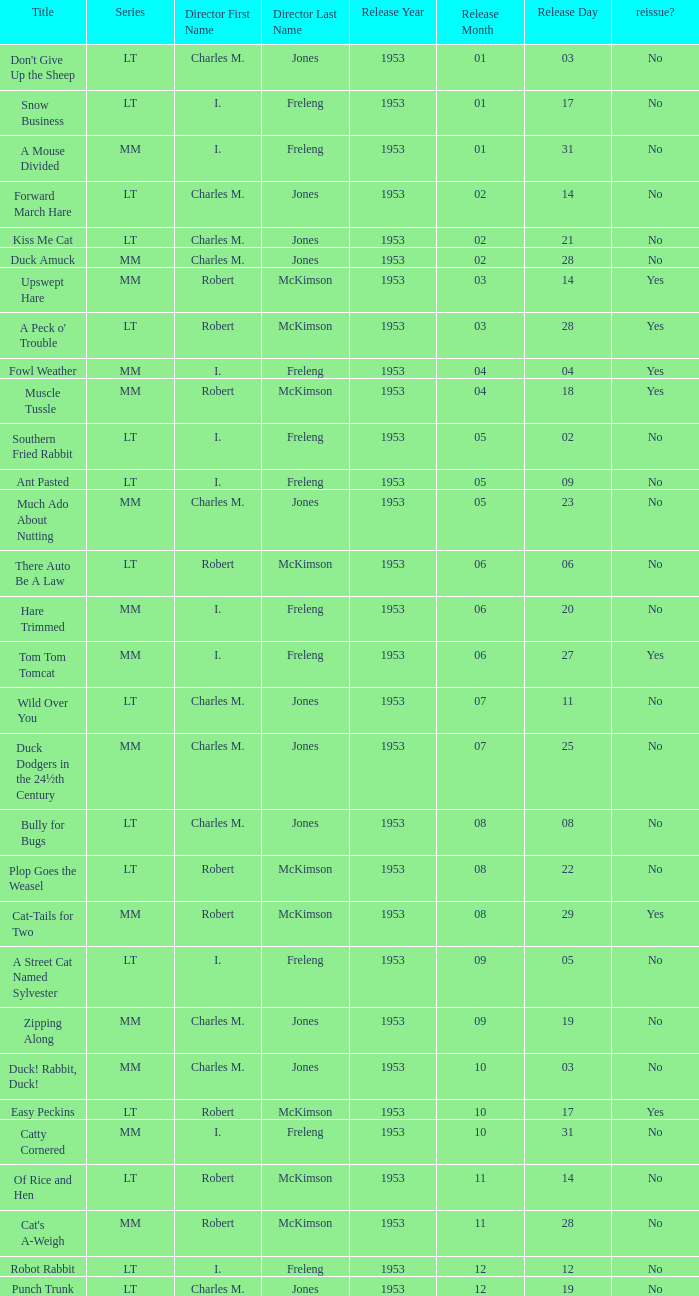What's the release date of Forward March Hare? 1953-02-14. 